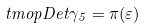<formula> <loc_0><loc_0><loc_500><loc_500>\ t m o p { D e t } \gamma _ { 5 } = \pi ( \varepsilon )</formula> 